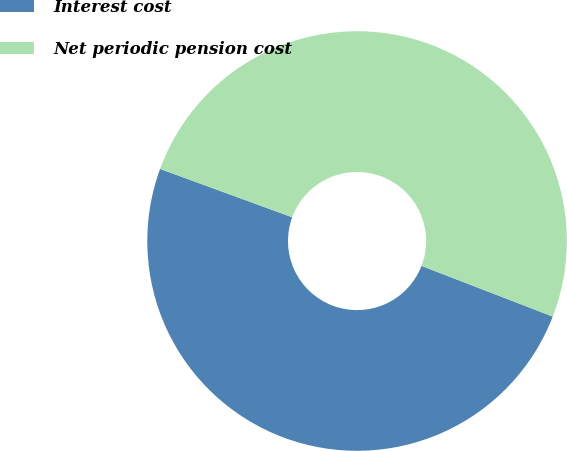Convert chart to OTSL. <chart><loc_0><loc_0><loc_500><loc_500><pie_chart><fcel>Interest cost<fcel>Net periodic pension cost<nl><fcel>49.72%<fcel>50.28%<nl></chart> 